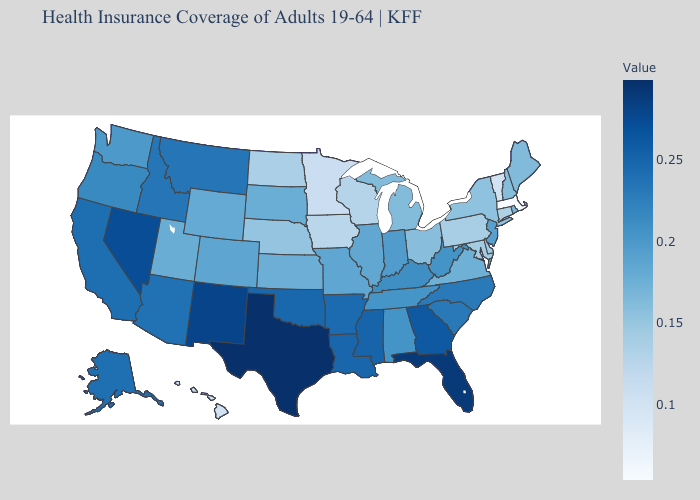Which states hav the highest value in the MidWest?
Write a very short answer. Indiana. Does Wyoming have the lowest value in the USA?
Keep it brief. No. Does the map have missing data?
Answer briefly. No. Does the map have missing data?
Concise answer only. No. Which states have the highest value in the USA?
Quick response, please. Texas. 